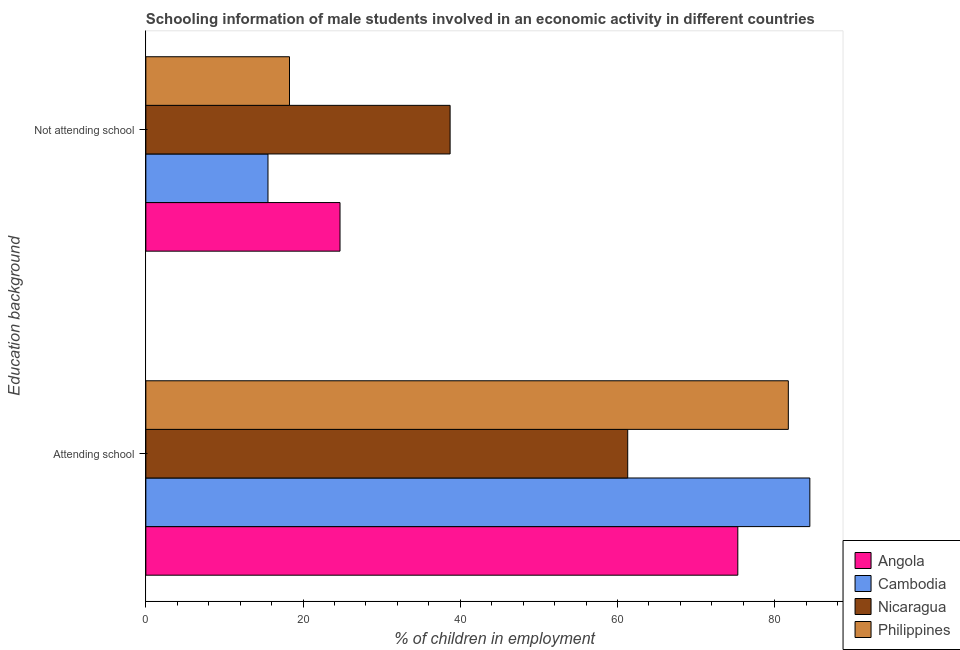How many different coloured bars are there?
Offer a very short reply. 4. How many groups of bars are there?
Keep it short and to the point. 2. How many bars are there on the 2nd tick from the top?
Make the answer very short. 4. What is the label of the 1st group of bars from the top?
Make the answer very short. Not attending school. What is the percentage of employed males who are attending school in Nicaragua?
Keep it short and to the point. 61.3. Across all countries, what is the maximum percentage of employed males who are attending school?
Your answer should be compact. 84.46. Across all countries, what is the minimum percentage of employed males who are attending school?
Your answer should be very brief. 61.3. In which country was the percentage of employed males who are not attending school maximum?
Ensure brevity in your answer.  Nicaragua. In which country was the percentage of employed males who are attending school minimum?
Provide a short and direct response. Nicaragua. What is the total percentage of employed males who are attending school in the graph?
Offer a very short reply. 302.79. What is the difference between the percentage of employed males who are not attending school in Philippines and that in Cambodia?
Make the answer very short. 2.74. What is the difference between the percentage of employed males who are not attending school in Nicaragua and the percentage of employed males who are attending school in Philippines?
Make the answer very short. -43.02. What is the average percentage of employed males who are attending school per country?
Your response must be concise. 75.7. What is the difference between the percentage of employed males who are attending school and percentage of employed males who are not attending school in Cambodia?
Make the answer very short. 68.93. In how many countries, is the percentage of employed males who are attending school greater than 32 %?
Ensure brevity in your answer.  4. What is the ratio of the percentage of employed males who are not attending school in Philippines to that in Cambodia?
Your response must be concise. 1.18. In how many countries, is the percentage of employed males who are not attending school greater than the average percentage of employed males who are not attending school taken over all countries?
Provide a succinct answer. 2. What does the 1st bar from the top in Attending school represents?
Offer a terse response. Philippines. What does the 1st bar from the bottom in Not attending school represents?
Give a very brief answer. Angola. How many countries are there in the graph?
Provide a short and direct response. 4. Does the graph contain any zero values?
Keep it short and to the point. No. Does the graph contain grids?
Offer a terse response. No. Where does the legend appear in the graph?
Your answer should be very brief. Bottom right. What is the title of the graph?
Give a very brief answer. Schooling information of male students involved in an economic activity in different countries. What is the label or title of the X-axis?
Your answer should be very brief. % of children in employment. What is the label or title of the Y-axis?
Give a very brief answer. Education background. What is the % of children in employment in Angola in Attending school?
Ensure brevity in your answer.  75.3. What is the % of children in employment of Cambodia in Attending school?
Ensure brevity in your answer.  84.46. What is the % of children in employment in Nicaragua in Attending school?
Your answer should be compact. 61.3. What is the % of children in employment in Philippines in Attending school?
Offer a terse response. 81.73. What is the % of children in employment of Angola in Not attending school?
Your response must be concise. 24.7. What is the % of children in employment in Cambodia in Not attending school?
Keep it short and to the point. 15.54. What is the % of children in employment in Nicaragua in Not attending school?
Your response must be concise. 38.7. What is the % of children in employment of Philippines in Not attending school?
Your answer should be compact. 18.27. Across all Education background, what is the maximum % of children in employment in Angola?
Your response must be concise. 75.3. Across all Education background, what is the maximum % of children in employment in Cambodia?
Offer a terse response. 84.46. Across all Education background, what is the maximum % of children in employment in Nicaragua?
Provide a short and direct response. 61.3. Across all Education background, what is the maximum % of children in employment in Philippines?
Give a very brief answer. 81.73. Across all Education background, what is the minimum % of children in employment of Angola?
Keep it short and to the point. 24.7. Across all Education background, what is the minimum % of children in employment in Cambodia?
Provide a succinct answer. 15.54. Across all Education background, what is the minimum % of children in employment in Nicaragua?
Give a very brief answer. 38.7. Across all Education background, what is the minimum % of children in employment in Philippines?
Your answer should be compact. 18.27. What is the total % of children in employment in Nicaragua in the graph?
Your answer should be compact. 100. What is the difference between the % of children in employment in Angola in Attending school and that in Not attending school?
Your answer should be very brief. 50.6. What is the difference between the % of children in employment of Cambodia in Attending school and that in Not attending school?
Provide a short and direct response. 68.93. What is the difference between the % of children in employment in Nicaragua in Attending school and that in Not attending school?
Your response must be concise. 22.59. What is the difference between the % of children in employment in Philippines in Attending school and that in Not attending school?
Keep it short and to the point. 63.45. What is the difference between the % of children in employment of Angola in Attending school and the % of children in employment of Cambodia in Not attending school?
Provide a short and direct response. 59.76. What is the difference between the % of children in employment in Angola in Attending school and the % of children in employment in Nicaragua in Not attending school?
Your answer should be very brief. 36.6. What is the difference between the % of children in employment of Angola in Attending school and the % of children in employment of Philippines in Not attending school?
Provide a succinct answer. 57.03. What is the difference between the % of children in employment in Cambodia in Attending school and the % of children in employment in Nicaragua in Not attending school?
Offer a very short reply. 45.76. What is the difference between the % of children in employment of Cambodia in Attending school and the % of children in employment of Philippines in Not attending school?
Offer a very short reply. 66.19. What is the difference between the % of children in employment in Nicaragua in Attending school and the % of children in employment in Philippines in Not attending school?
Provide a succinct answer. 43.02. What is the average % of children in employment of Angola per Education background?
Give a very brief answer. 50. What is the average % of children in employment of Nicaragua per Education background?
Ensure brevity in your answer.  50. What is the average % of children in employment in Philippines per Education background?
Make the answer very short. 50. What is the difference between the % of children in employment in Angola and % of children in employment in Cambodia in Attending school?
Provide a short and direct response. -9.16. What is the difference between the % of children in employment of Angola and % of children in employment of Nicaragua in Attending school?
Your answer should be compact. 14. What is the difference between the % of children in employment of Angola and % of children in employment of Philippines in Attending school?
Your answer should be compact. -6.43. What is the difference between the % of children in employment in Cambodia and % of children in employment in Nicaragua in Attending school?
Give a very brief answer. 23.17. What is the difference between the % of children in employment of Cambodia and % of children in employment of Philippines in Attending school?
Give a very brief answer. 2.74. What is the difference between the % of children in employment in Nicaragua and % of children in employment in Philippines in Attending school?
Offer a very short reply. -20.43. What is the difference between the % of children in employment in Angola and % of children in employment in Cambodia in Not attending school?
Provide a succinct answer. 9.16. What is the difference between the % of children in employment in Angola and % of children in employment in Nicaragua in Not attending school?
Your answer should be very brief. -14. What is the difference between the % of children in employment of Angola and % of children in employment of Philippines in Not attending school?
Make the answer very short. 6.43. What is the difference between the % of children in employment in Cambodia and % of children in employment in Nicaragua in Not attending school?
Your answer should be compact. -23.17. What is the difference between the % of children in employment in Cambodia and % of children in employment in Philippines in Not attending school?
Offer a terse response. -2.74. What is the difference between the % of children in employment of Nicaragua and % of children in employment of Philippines in Not attending school?
Give a very brief answer. 20.43. What is the ratio of the % of children in employment in Angola in Attending school to that in Not attending school?
Ensure brevity in your answer.  3.05. What is the ratio of the % of children in employment of Cambodia in Attending school to that in Not attending school?
Offer a terse response. 5.44. What is the ratio of the % of children in employment in Nicaragua in Attending school to that in Not attending school?
Make the answer very short. 1.58. What is the ratio of the % of children in employment of Philippines in Attending school to that in Not attending school?
Provide a short and direct response. 4.47. What is the difference between the highest and the second highest % of children in employment in Angola?
Provide a succinct answer. 50.6. What is the difference between the highest and the second highest % of children in employment in Cambodia?
Offer a terse response. 68.93. What is the difference between the highest and the second highest % of children in employment of Nicaragua?
Ensure brevity in your answer.  22.59. What is the difference between the highest and the second highest % of children in employment of Philippines?
Give a very brief answer. 63.45. What is the difference between the highest and the lowest % of children in employment in Angola?
Offer a very short reply. 50.6. What is the difference between the highest and the lowest % of children in employment of Cambodia?
Offer a very short reply. 68.93. What is the difference between the highest and the lowest % of children in employment of Nicaragua?
Offer a very short reply. 22.59. What is the difference between the highest and the lowest % of children in employment of Philippines?
Ensure brevity in your answer.  63.45. 